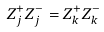<formula> <loc_0><loc_0><loc_500><loc_500>Z _ { j } ^ { + } Z _ { j } ^ { - } = Z _ { k } ^ { + } Z _ { k } ^ { - }</formula> 